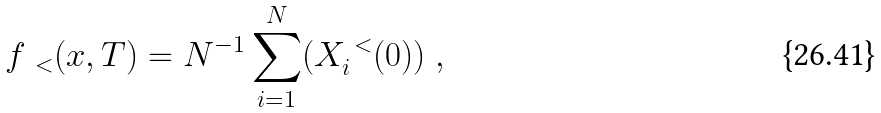Convert formula to latex. <formula><loc_0><loc_0><loc_500><loc_500>f _ { \, \ < } ( x , T ) = N ^ { - 1 } \sum _ { i = 1 } ^ { N } ( X _ { i } ^ { \ < } ( 0 ) ) \ ,</formula> 